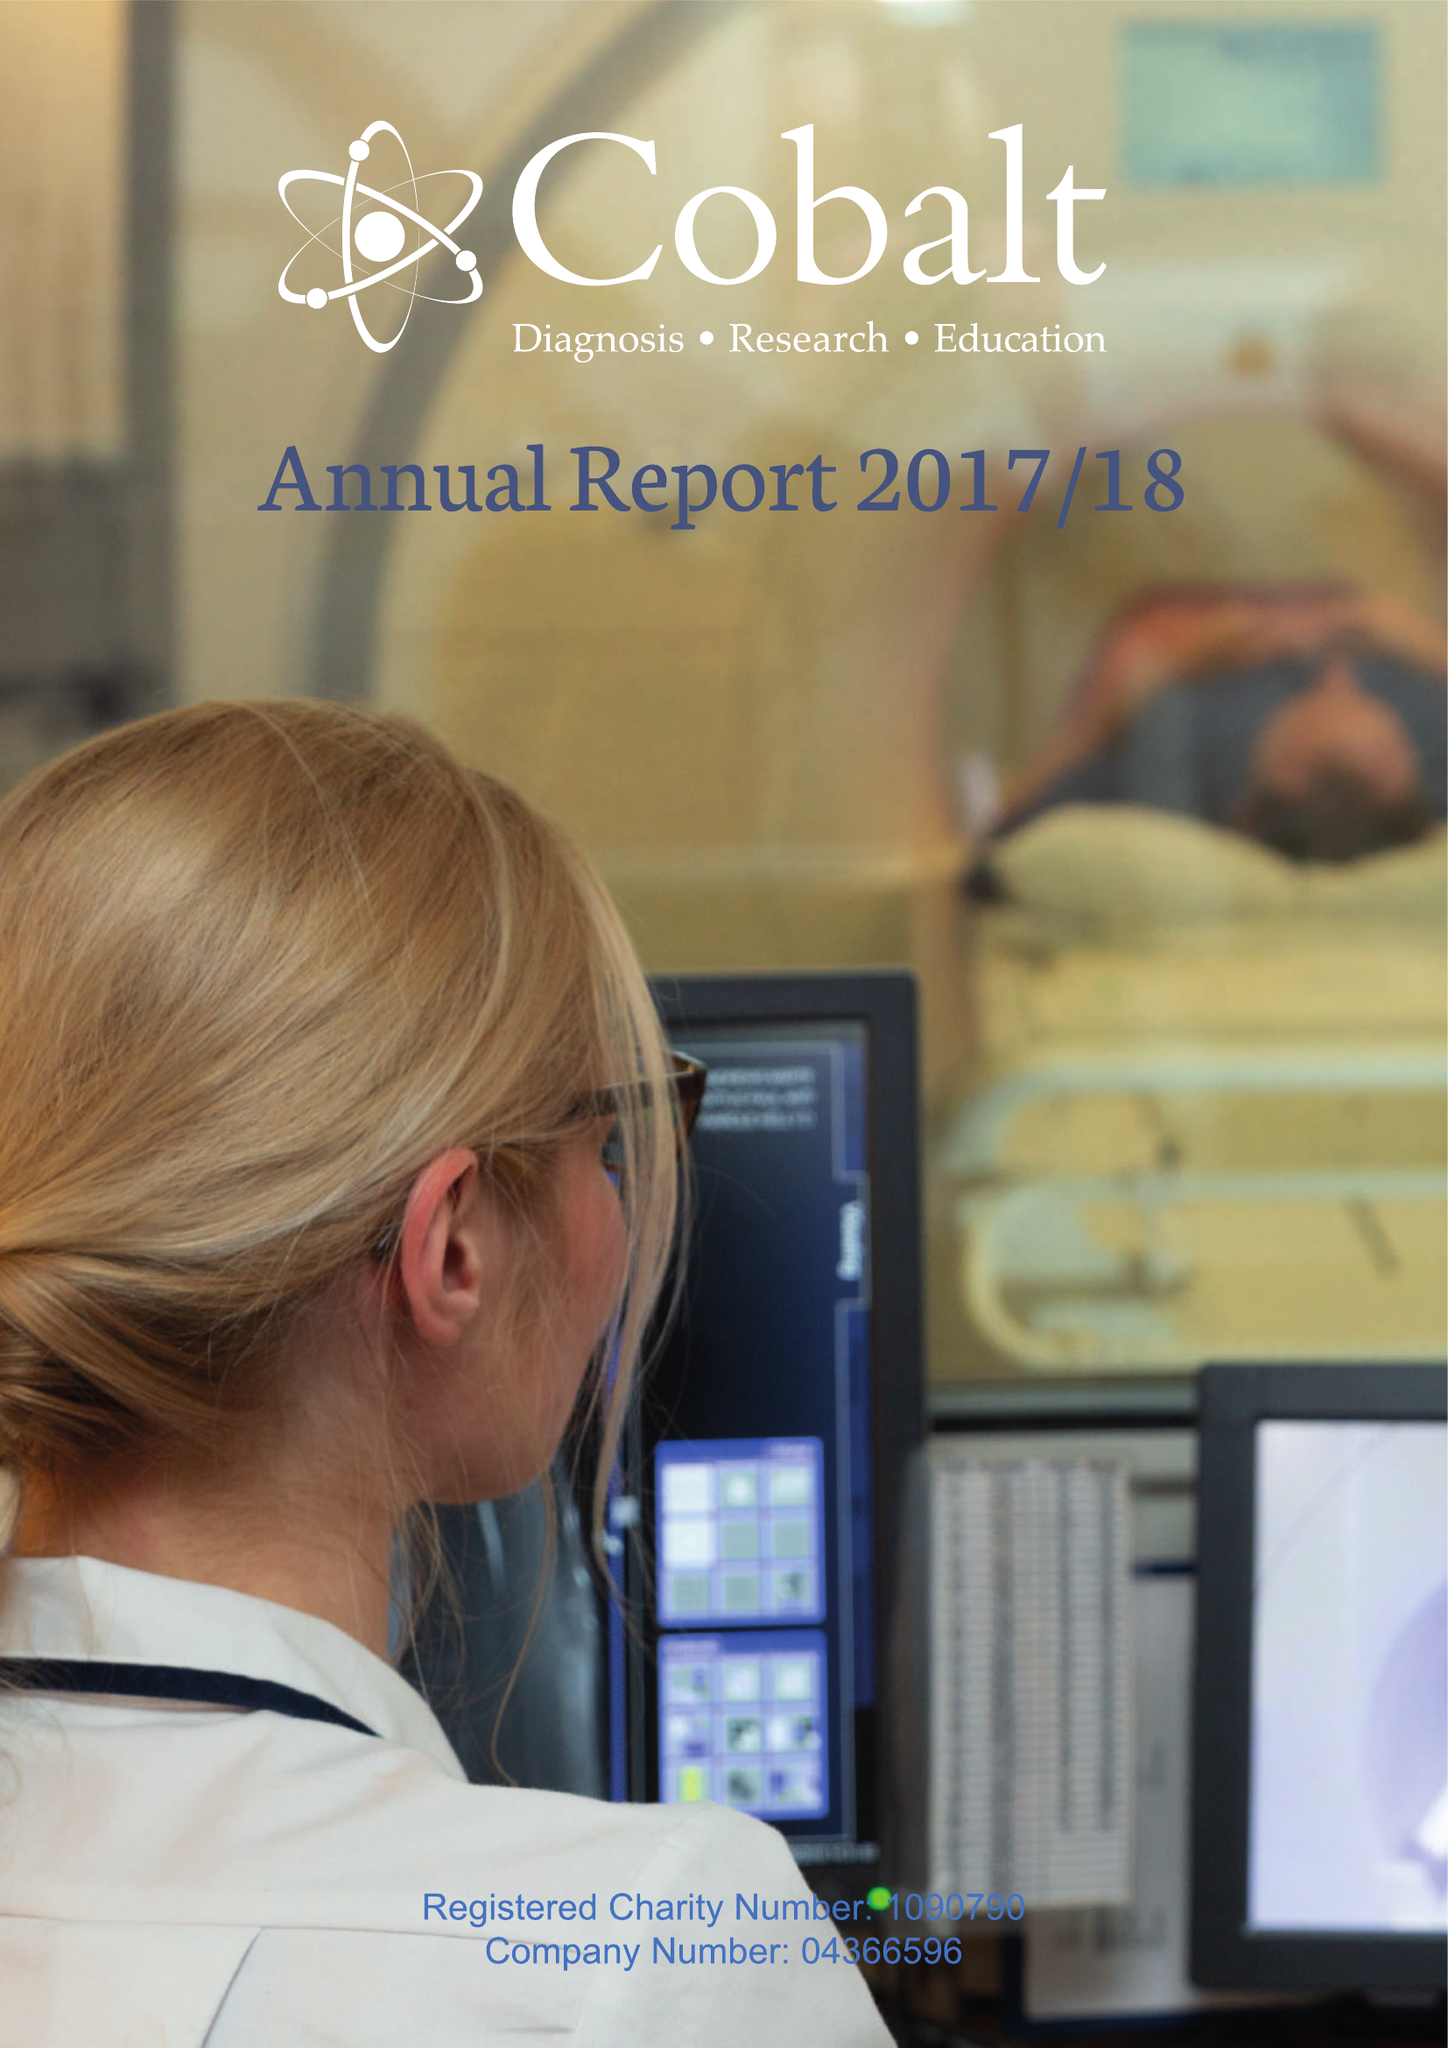What is the value for the address__street_line?
Answer the question using a single word or phrase. THIRLESTAINE ROAD 